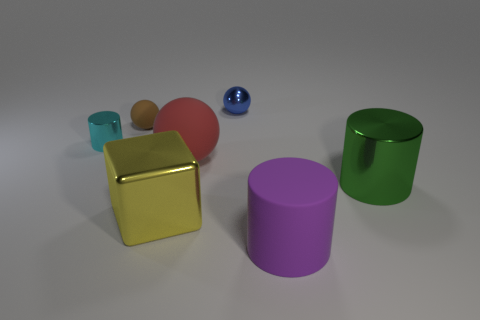There is a purple object that is the same size as the red rubber sphere; what shape is it?
Keep it short and to the point. Cylinder. What number of other things are the same shape as the tiny cyan thing?
Offer a terse response. 2. There is a brown rubber object; is it the same size as the metal cylinder on the right side of the cyan object?
Make the answer very short. No. What number of things are either shiny cylinders that are behind the big cube or yellow things?
Give a very brief answer. 3. What shape is the large shiny object on the right side of the tiny blue object?
Give a very brief answer. Cylinder. Is the number of big yellow things that are behind the yellow shiny object the same as the number of rubber things on the left side of the tiny blue sphere?
Provide a short and direct response. No. There is a object that is both in front of the tiny brown sphere and on the left side of the big block; what is its color?
Offer a terse response. Cyan. What is the material of the cylinder to the left of the sphere on the right side of the large red rubber sphere?
Offer a terse response. Metal. Is the size of the purple rubber cylinder the same as the green metal cylinder?
Provide a short and direct response. Yes. What number of small objects are either green metallic cylinders or purple spheres?
Offer a very short reply. 0. 